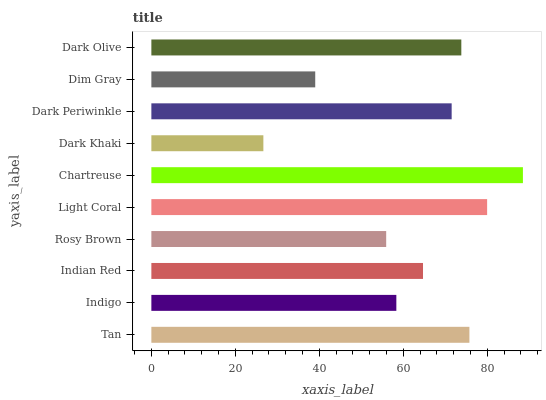Is Dark Khaki the minimum?
Answer yes or no. Yes. Is Chartreuse the maximum?
Answer yes or no. Yes. Is Indigo the minimum?
Answer yes or no. No. Is Indigo the maximum?
Answer yes or no. No. Is Tan greater than Indigo?
Answer yes or no. Yes. Is Indigo less than Tan?
Answer yes or no. Yes. Is Indigo greater than Tan?
Answer yes or no. No. Is Tan less than Indigo?
Answer yes or no. No. Is Dark Periwinkle the high median?
Answer yes or no. Yes. Is Indian Red the low median?
Answer yes or no. Yes. Is Chartreuse the high median?
Answer yes or no. No. Is Dark Khaki the low median?
Answer yes or no. No. 